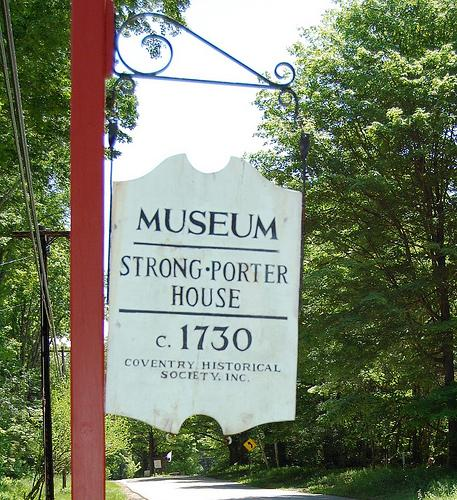Question: what is the first word on the sign?
Choices:
A. Stop.
B. Museum.
C. Enter.
D. Restricted.
Answer with the letter. Answer: B Question: what number is on the sign?
Choices:
A. 1840.
B. 1203.
C. 61.
D. 1730.
Answer with the letter. Answer: D 